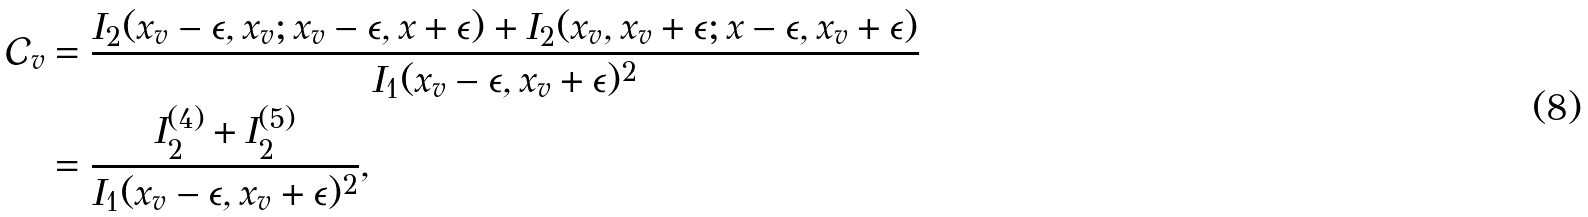<formula> <loc_0><loc_0><loc_500><loc_500>\mathcal { C } _ { v } & = \frac { I _ { 2 } ( x _ { v } - \epsilon , x _ { v } ; x _ { v } - \epsilon , x + \epsilon ) + I _ { 2 } ( x _ { v } , x _ { v } + \epsilon ; x - \epsilon , x _ { v } + \epsilon ) } { I _ { 1 } ( x _ { v } - \epsilon , x _ { v } + \epsilon ) ^ { 2 } } \\ & = \frac { I _ { 2 } ^ { ( 4 ) } + I _ { 2 } ^ { ( 5 ) } } { I _ { 1 } ( x _ { v } - \epsilon , x _ { v } + \epsilon ) ^ { 2 } } ,</formula> 